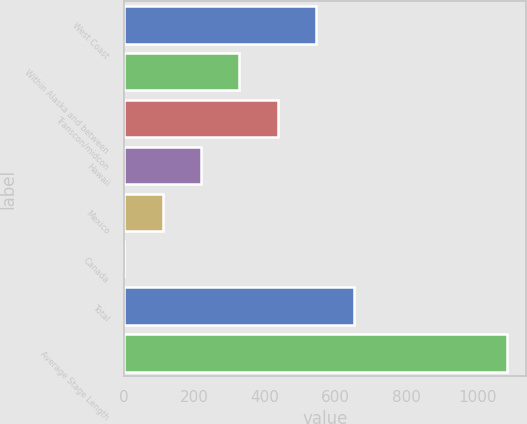Convert chart to OTSL. <chart><loc_0><loc_0><loc_500><loc_500><bar_chart><fcel>West Coast<fcel>Within Alaska and between<fcel>Transcon/midcon<fcel>Hawaii<fcel>Mexico<fcel>Canada<fcel>Total<fcel>Average Stage Length<nl><fcel>543.5<fcel>326.9<fcel>435.2<fcel>218.6<fcel>110.3<fcel>2<fcel>651.8<fcel>1085<nl></chart> 